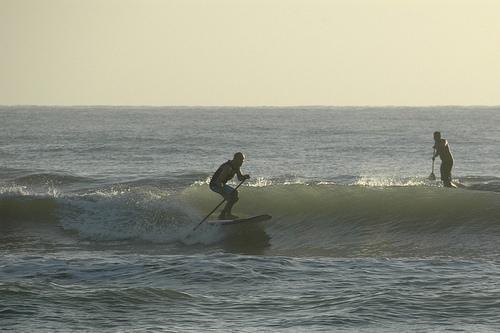How many people are the picture?
Give a very brief answer. 2. 